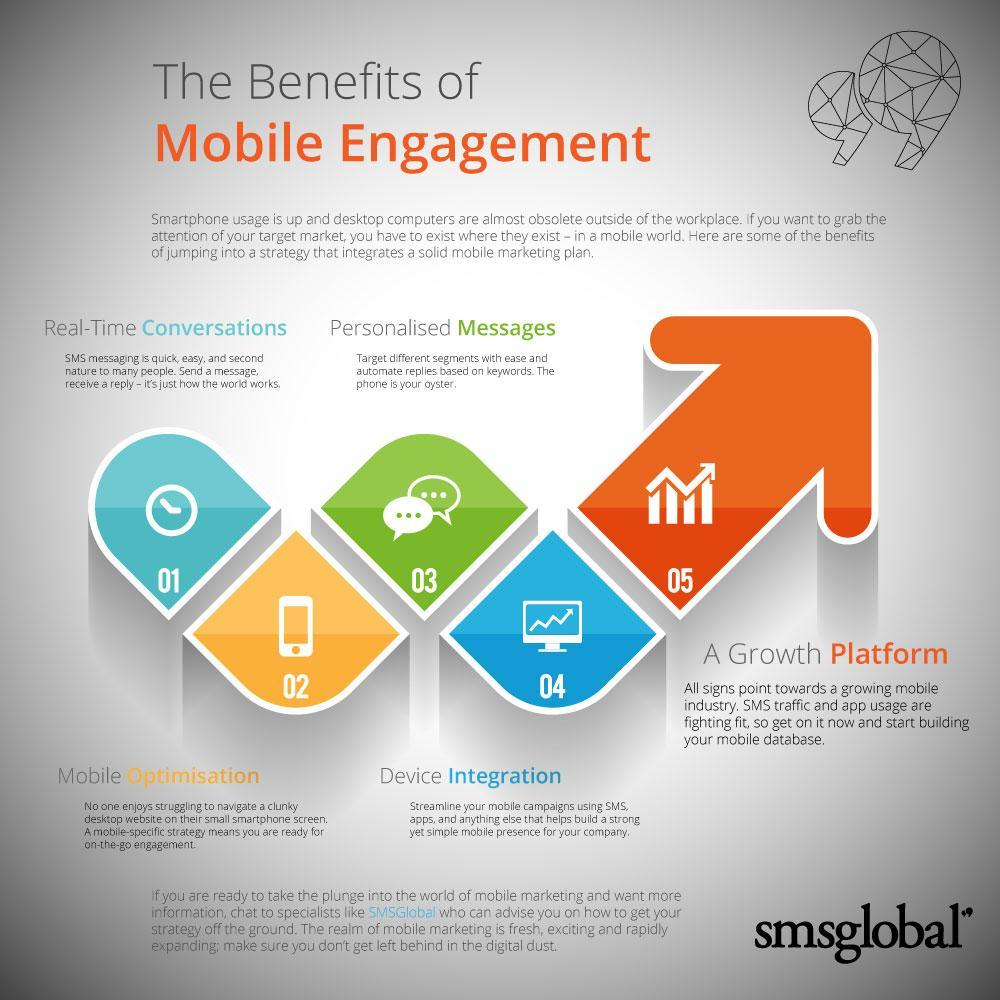What is the 4th benefit of mobile engagament
Answer the question with a short phrase. Device integration What will replace desktop computers outside of the workplace smartphone What is the 3rd benefit of mobile engagement Personalised Messages What is the 2nd benefit of mobile engagement Mobile Optimisation What helps target different segments with ease Personalised Messages 